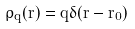<formula> <loc_0><loc_0><loc_500><loc_500>\rho _ { q } ( r ) = q \delta ( r - r _ { 0 } )</formula> 